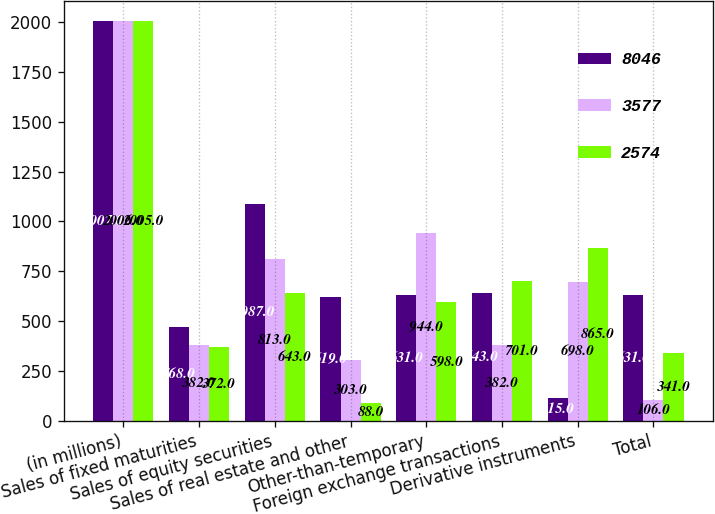Convert chart to OTSL. <chart><loc_0><loc_0><loc_500><loc_500><stacked_bar_chart><ecel><fcel>(in millions)<fcel>Sales of fixed maturities<fcel>Sales of equity securities<fcel>Sales of real estate and other<fcel>Other-than-temporary<fcel>Foreign exchange transactions<fcel>Derivative instruments<fcel>Total<nl><fcel>8046<fcel>2007<fcel>468<fcel>1087<fcel>619<fcel>631<fcel>643<fcel>115<fcel>631<nl><fcel>3577<fcel>2006<fcel>382<fcel>813<fcel>303<fcel>944<fcel>382<fcel>698<fcel>106<nl><fcel>2574<fcel>2005<fcel>372<fcel>643<fcel>88<fcel>598<fcel>701<fcel>865<fcel>341<nl></chart> 